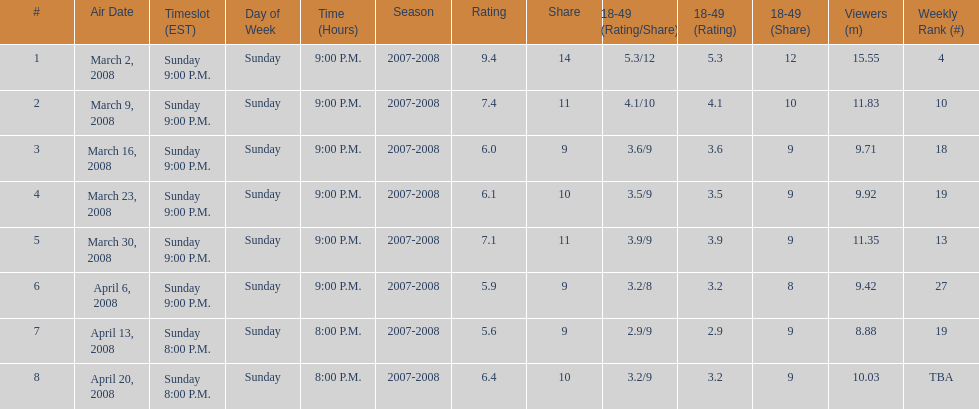Parse the full table. {'header': ['#', 'Air Date', 'Timeslot (EST)', 'Day of Week', 'Time (Hours)', 'Season', 'Rating', 'Share', '18-49 (Rating/Share)', '18-49 (Rating)', '18-49 (Share)', 'Viewers (m)', 'Weekly Rank (#)'], 'rows': [['1', 'March 2, 2008', 'Sunday 9:00 P.M.', 'Sunday', '9:00 P.M.', '2007-2008', '9.4', '14', '5.3/12', '5.3', '12', '15.55', '4'], ['2', 'March 9, 2008', 'Sunday 9:00 P.M.', 'Sunday', '9:00 P.M.', '2007-2008', '7.4', '11', '4.1/10', '4.1', '10', '11.83', '10'], ['3', 'March 16, 2008', 'Sunday 9:00 P.M.', 'Sunday', '9:00 P.M.', '2007-2008', '6.0', '9', '3.6/9', '3.6', '9', '9.71', '18'], ['4', 'March 23, 2008', 'Sunday 9:00 P.M.', 'Sunday', '9:00 P.M.', '2007-2008', '6.1', '10', '3.5/9', '3.5', '9', '9.92', '19'], ['5', 'March 30, 2008', 'Sunday 9:00 P.M.', 'Sunday', '9:00 P.M.', '2007-2008', '7.1', '11', '3.9/9', '3.9', '9', '11.35', '13'], ['6', 'April 6, 2008', 'Sunday 9:00 P.M.', 'Sunday', '9:00 P.M.', '2007-2008', '5.9', '9', '3.2/8', '3.2', '8', '9.42', '27'], ['7', 'April 13, 2008', 'Sunday 8:00 P.M.', 'Sunday', '8:00 P.M.', '2007-2008', '5.6', '9', '2.9/9', '2.9', '9', '8.88', '19'], ['8', 'April 20, 2008', 'Sunday 8:00 P.M.', 'Sunday', '8:00 P.M.', '2007-2008', '6.4', '10', '3.2/9', '3.2', '9', '10.03', 'TBA']]} How many shows had more than 10 million viewers? 4. 